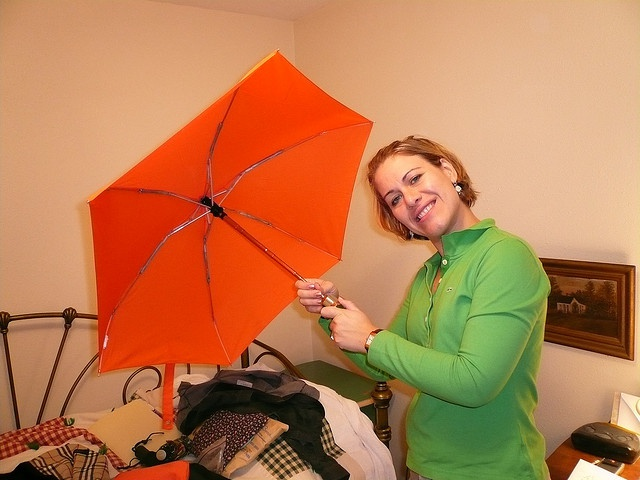Describe the objects in this image and their specific colors. I can see umbrella in tan, red, brown, and orange tones, people in tan, green, and lightgreen tones, bed in tan, salmon, and maroon tones, and clock in tan, black, maroon, and brown tones in this image. 